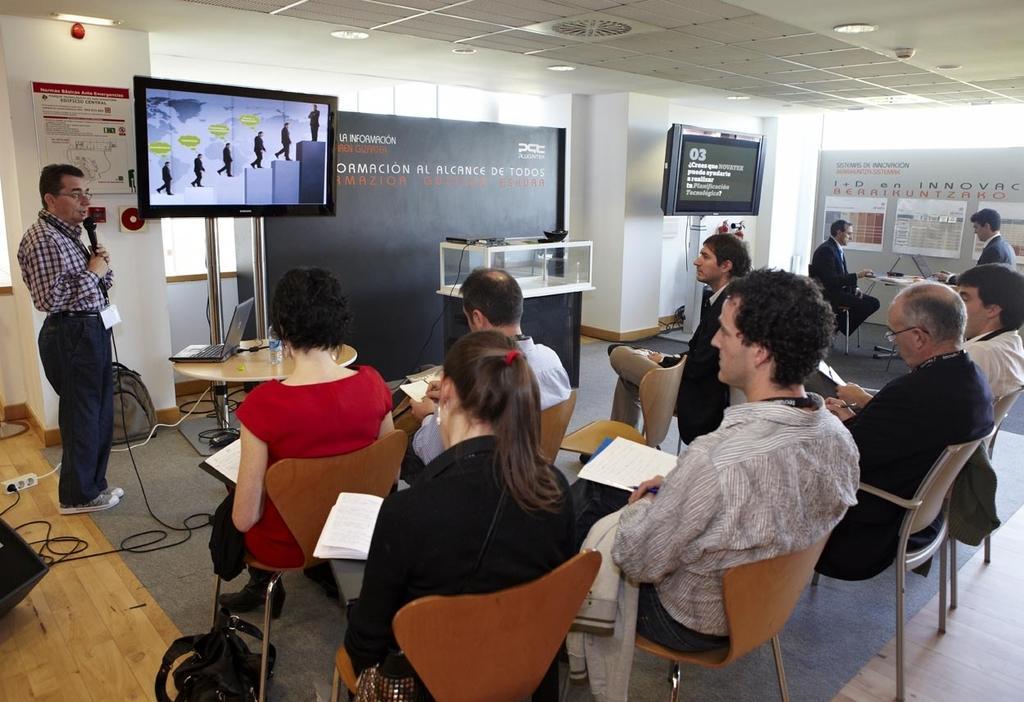In one or two sentences, can you explain what this image depicts? This image consists of many people sitting in a room. On the left, there is a man talking in a mic. In the front, we can see there are two screens. In the middle, there is a banner. At the top, there is a roof. At the bottom, there is a floor. And we can see the pillars in the front. 